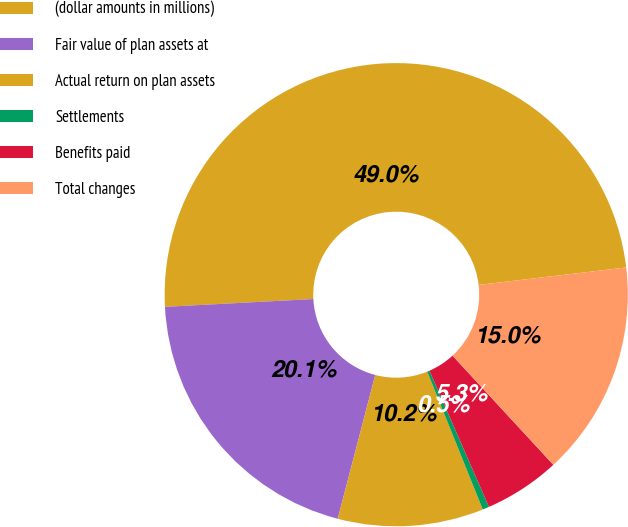<chart> <loc_0><loc_0><loc_500><loc_500><pie_chart><fcel>(dollar amounts in millions)<fcel>Fair value of plan assets at<fcel>Actual return on plan assets<fcel>Settlements<fcel>Benefits paid<fcel>Total changes<nl><fcel>48.96%<fcel>20.1%<fcel>10.16%<fcel>0.46%<fcel>5.31%<fcel>15.01%<nl></chart> 